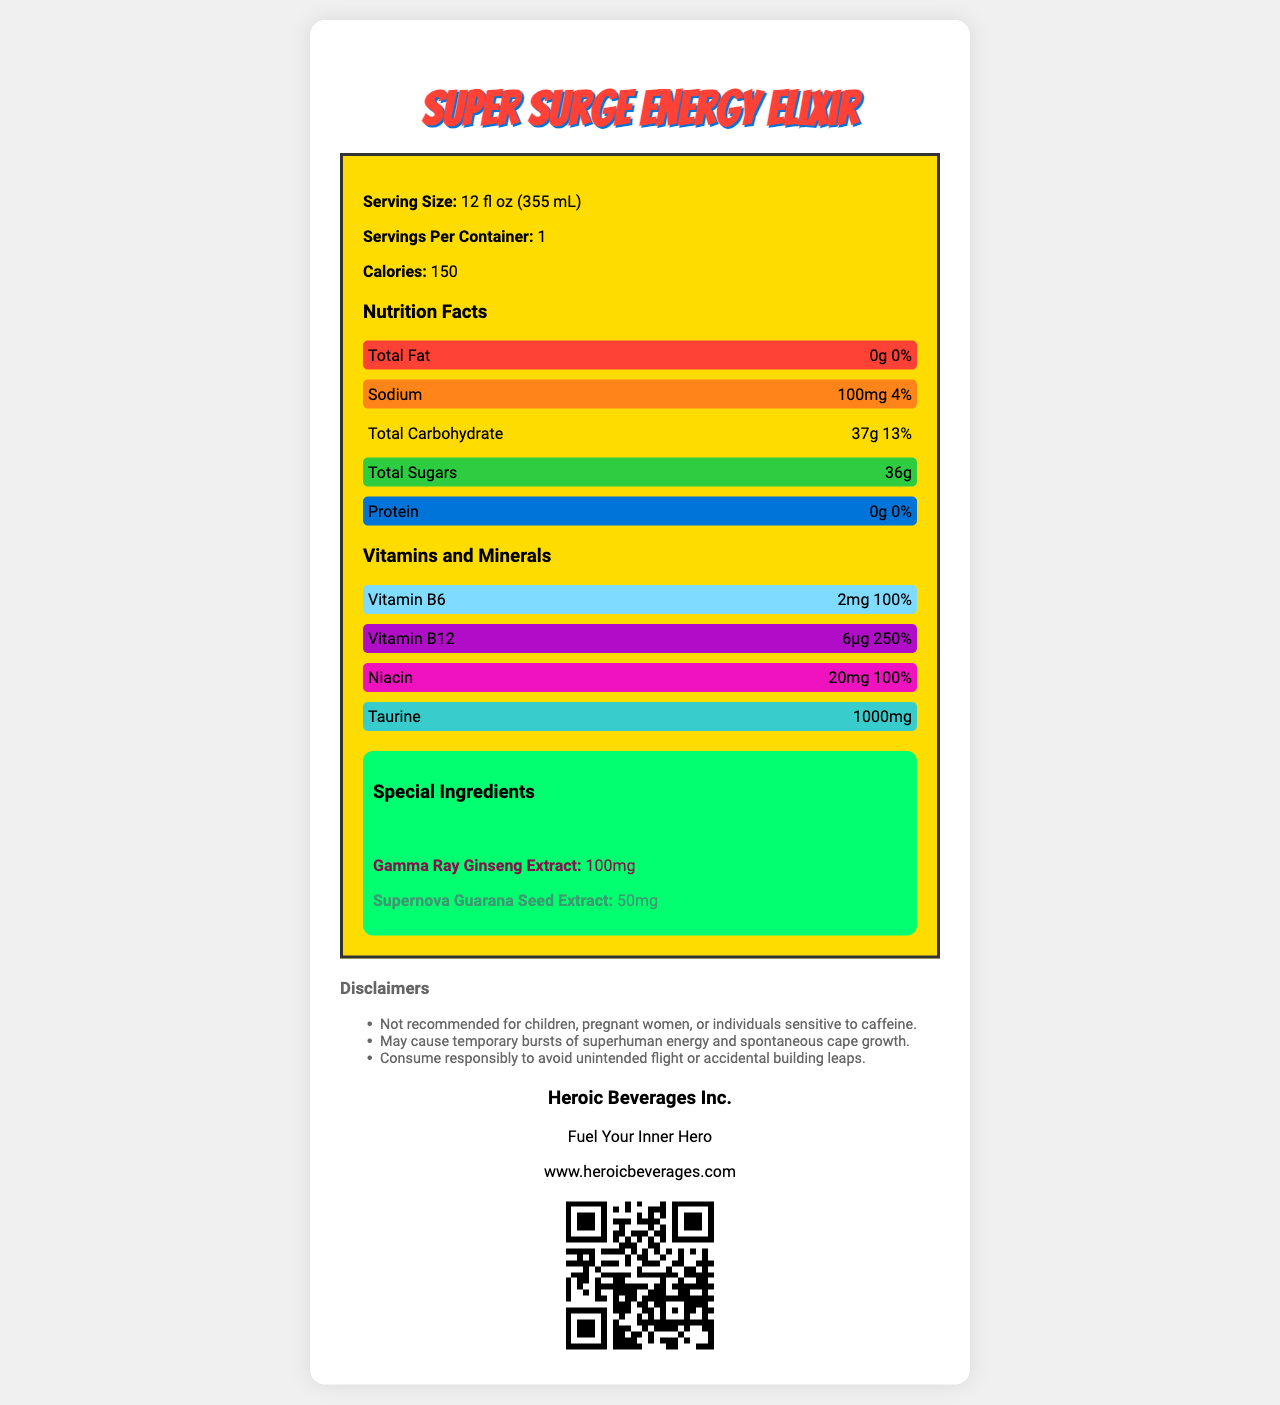what is the serving size of Super Surge Energy Elixir? The serving size is directly mentioned in the document under the "Serving Size" section.
Answer: 12 fl oz (355 mL) how many calories are in a single serving of Super Surge Energy Elixir? The document states the number of calories per serving as 150.
Answer: 150 which nutrient has the highest daily value percentage? Vitamin B12 has a daily value percentage of 250%, which is the highest among the listed nutrients.
Answer: Vitamin B12 name two special ingredients in the Super Surge Energy Elixir. The special ingredients listed include Cosmic Caffeine Blend and Gamma Ray Ginseng Extract.
Answer: Cosmic Caffeine Blend, Gamma Ray Ginseng Extract how much Sodium is present in the Super Surge Energy Elixir per serving? The amount of Sodium is specified as 100mg per serving in the document.
Answer: 100mg which color is used to highlight the "Total Sugars" nutrient section? The document indicates that the color for "Total Sugars" is #2ECC40.
Answer: #2ECC40 how many servings are there per container? A. 1 B. 2 C. 3 D. 4 The document mentions that there is 1 serving per container.
Answer: A which of the following nutrients has the amount of 1000mg? I. Taurine II. Sodium III. Niacin Taurine is listed with an amount of 1000mg.
Answer: I. Taurine is the Super Surge Energy Elixir recommended for children? One of the disclaimers mentions that the drink is not recommended for children.
Answer: No describe the main idea of the document. The document aims to inform consumers about the nutritional content, ingredients, and brand details of the energy drink while using a visually appealing design.
Answer: The document provides detailed nutrition facts, special ingredients, disclaimers, and brand information for the "Super Surge Energy Elixir," an energy drink from Heroic Beverages Inc. It includes vibrant, color-coded sections to visually highlight key nutritional information and ingredients. how many total carbohydrates are in the Super Surge Energy Elixir? The document specifies that the drink contains 37g of total carbohydrates.
Answer: 37g what company makes the Super Surge Energy Elixir? The brand information section states that Heroic Beverages Inc. makes the Super Surge Energy Elixir.
Answer: Heroic Beverages Inc. does the drink contain any fat? The document mentions that the drink contains 0g of Total Fat.
Answer: No what is the color associated with the "Gamma Ray Ginseng Extract" special ingredient? A. #2ECC40 B. #01FF70 C. #85144b The document indicates that the color for Gamma Ray Ginseng Extract is #85144b.
Answer: C what is the tagline for Heroic Beverages Inc.? The document lists the tagline of Heroic Beverages Inc. as "Fuel Your Inner Hero."
Answer: Fuel Your Inner Hero how much Vitamin B6 is in the Super Surge Energy Elixir? The document states that there is 2mg of Vitamin B6 in the drink.
Answer: 2mg does the product contain any vitamin C? The document does not provide any information regarding the presence of Vitamin C.
Answer: Cannot be determined 